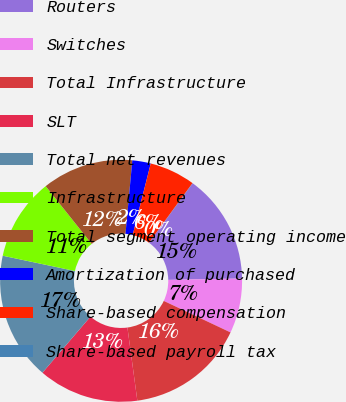Convert chart to OTSL. <chart><loc_0><loc_0><loc_500><loc_500><pie_chart><fcel>Routers<fcel>Switches<fcel>Total Infrastructure<fcel>SLT<fcel>Total net revenues<fcel>Infrastructure<fcel>Total segment operating income<fcel>Amortization of purchased<fcel>Share-based compensation<fcel>Share-based payroll tax<nl><fcel>14.62%<fcel>7.32%<fcel>15.84%<fcel>13.41%<fcel>17.06%<fcel>10.97%<fcel>12.19%<fcel>2.46%<fcel>6.11%<fcel>0.03%<nl></chart> 